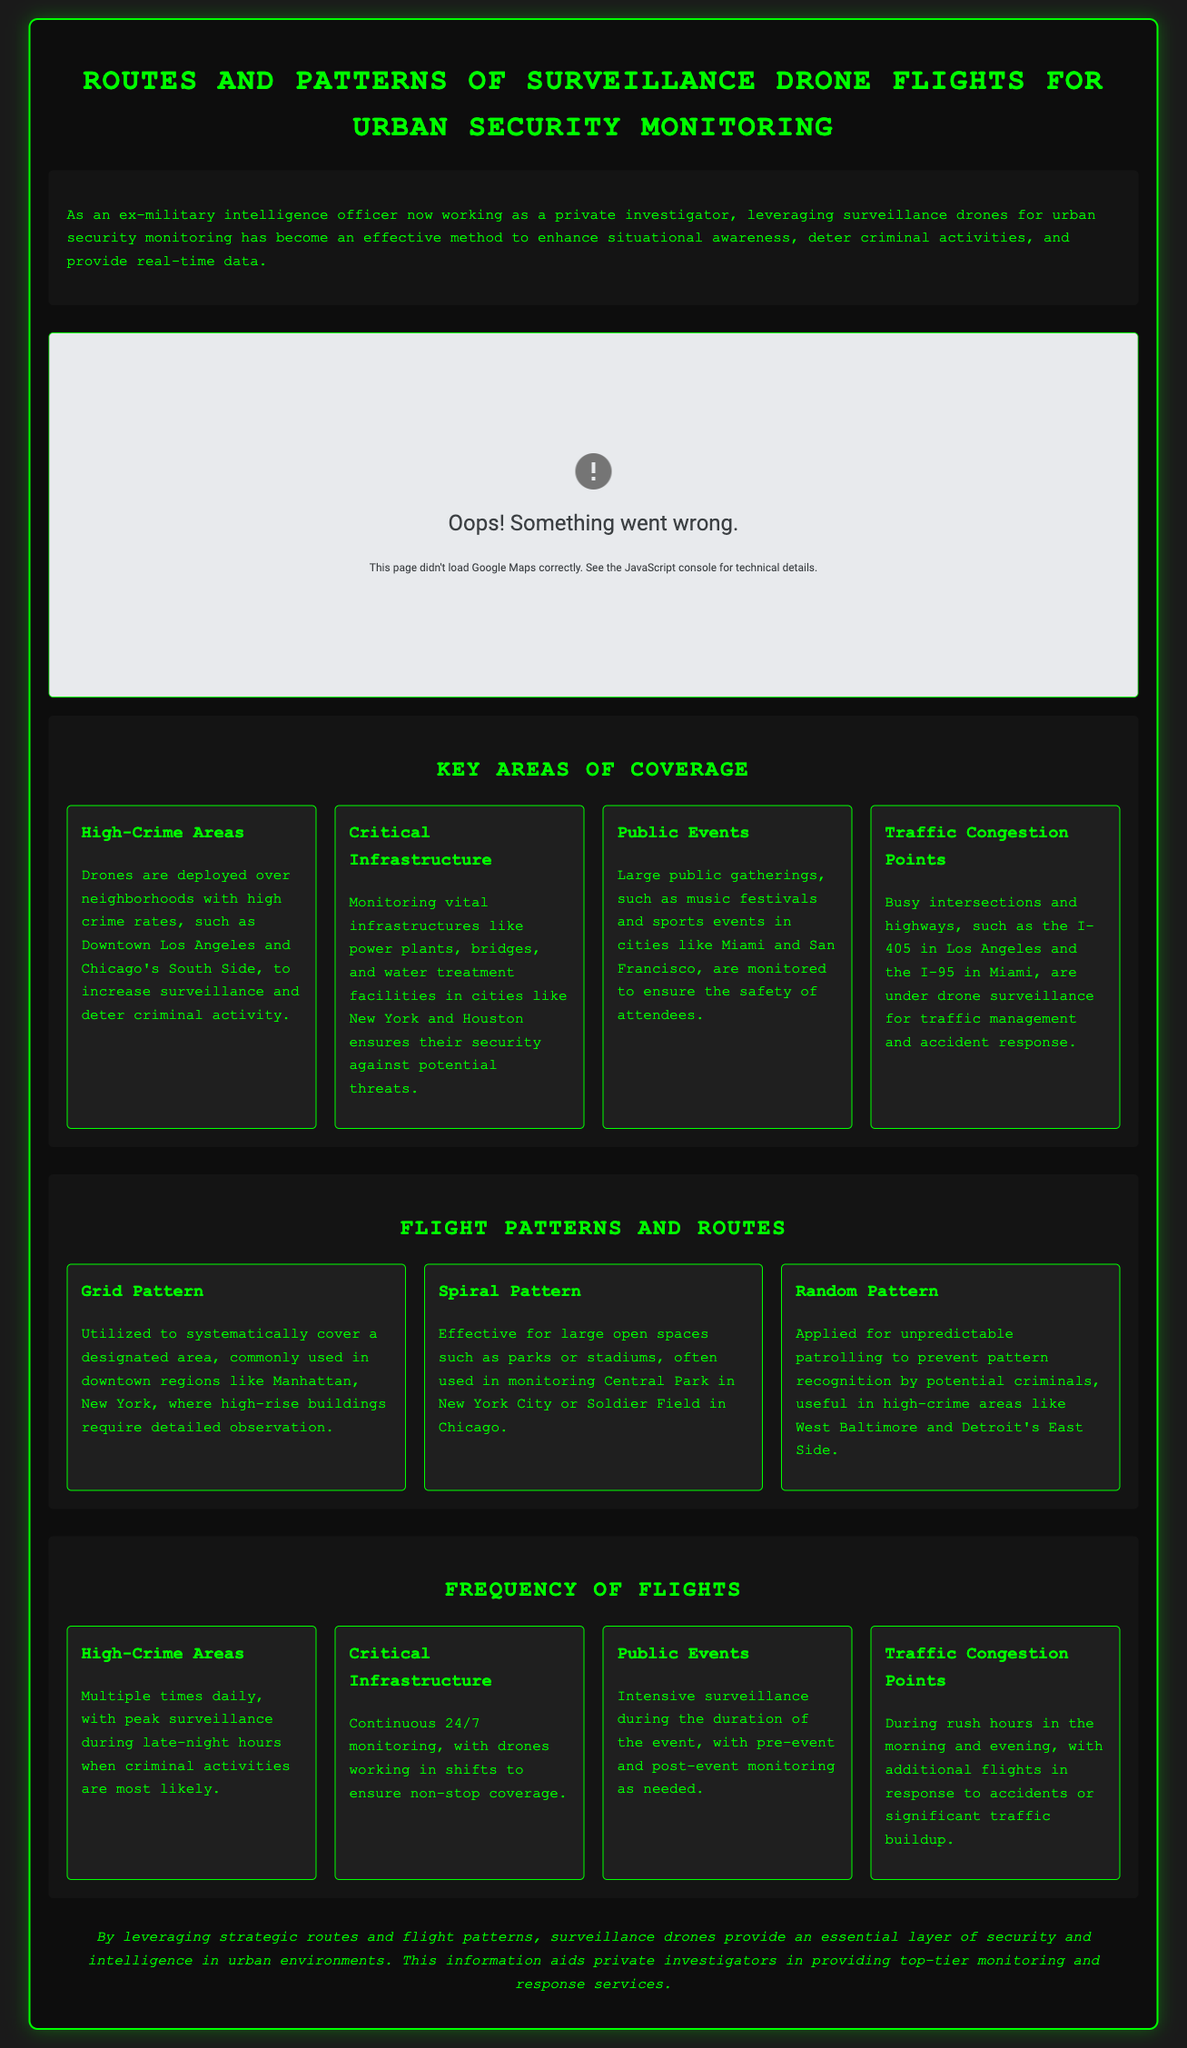what are the key areas of coverage for drone flights? The document outlines various areas, such as High-Crime Areas, Critical Infrastructure, Public Events, and Traffic Congestion Points.
Answer: High-Crime Areas, Critical Infrastructure, Public Events, Traffic Congestion Points which flight pattern is commonly used in downtown regions? It mentions that the Grid Pattern is utilized to systematically cover designated areas, especially in downtown regions like Manhattan.
Answer: Grid Pattern how frequently are drones deployed over high-crime areas? The text states that drones are deployed multiple times daily, with peak surveillance during late-night hours.
Answer: Multiple times daily which city is monitored for large public gatherings according to the document? The document lists Miami and San Francisco as cities where large public gatherings are monitored.
Answer: Miami, San Francisco what is the main purpose of deploying drones over critical infrastructure? The document specifies that monitoring vital infrastructures ensures their security against potential threats.
Answer: Security what flight pattern is suitable for large open spaces like parks? The Spiral Pattern is noted as effective for large open spaces.
Answer: Spiral Pattern how often are critical infrastructures monitored? According to the document, critical infrastructures are monitored continuously, 24/7.
Answer: 24/7 what is the primary function of drone surveillance during public events? The main function is to ensure safety, mentioned as intensive surveillance during the duration of the event.
Answer: Ensure safety which drone surveillance pattern is useful in preventing pattern recognition by criminals? The Random Pattern is applied to prevent recognizable patterns by potential criminals in high-crime areas.
Answer: Random Pattern 